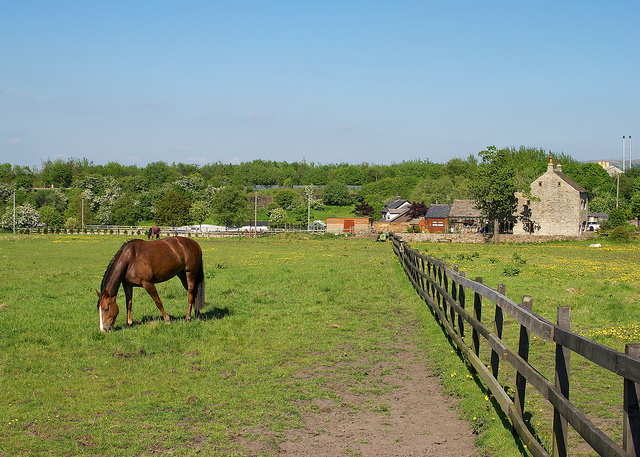How does this type of fencing compare to other options for keeping livestock safe? The wooden fencing seen in the image is robust and typically more aesthetically pleasing than other options like wire or electric fencing. It provides a clear physical barrier without the risk of injuring the animals as some wire fences might. However, it requires more maintenance to prevent decay and damage over time. Each type of fencing has its advantages and suitability depending on the budget, type of livestock, and the topographical features of the land. 